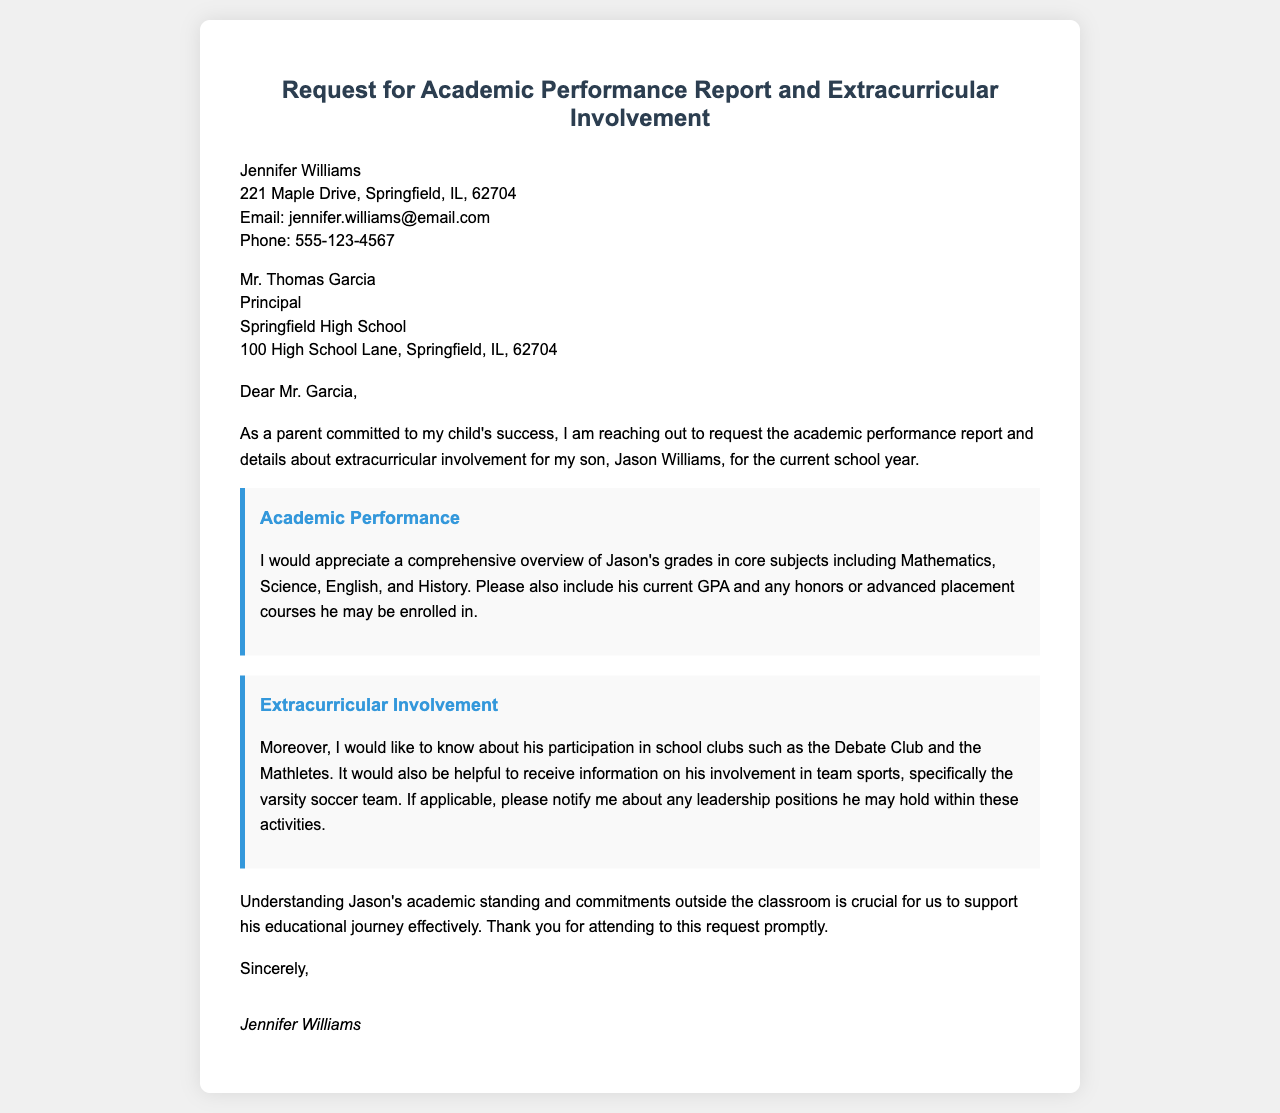What is the sender's name? The sender's name is specified in the document as the person who wrote the letter.
Answer: Jennifer Williams What is the recipient's title? The recipient's title is mentioned in the letter as part of the introduction.
Answer: Principal What is Jason's mother's email address? The document provides the email contact for the sender as part of the sender information.
Answer: jennifer.williams@email.com What subjects are requested for the academic performance report? The letter specifies the subjects that need to be included in the performance report.
Answer: Mathematics, Science, English, History What is the purpose of the letter? The intent of the letter is stated in the introductory paragraph.
Answer: To request the academic performance report and extracurricular involvement Is Jason involved in team sports? The document asks for information about Jason's activities in school teams.
Answer: Yes What leadership positions is Jason asked to report on? The letter specifically inquires about any roles Jason may hold in his extracurricular activities.
Answer: Leadership positions in clubs or teams What is the importance of understanding Jason's standing? The letter mentions a reason for the request that involves supporting Jason's journey.
Answer: To support his educational journey effectively What is the signature style of the letter? The document describes how the sender signed off at the end of the letter.
Answer: Italic 